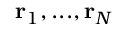<formula> <loc_0><loc_0><loc_500><loc_500>r _ { 1 } , \dots , r _ { N }</formula> 